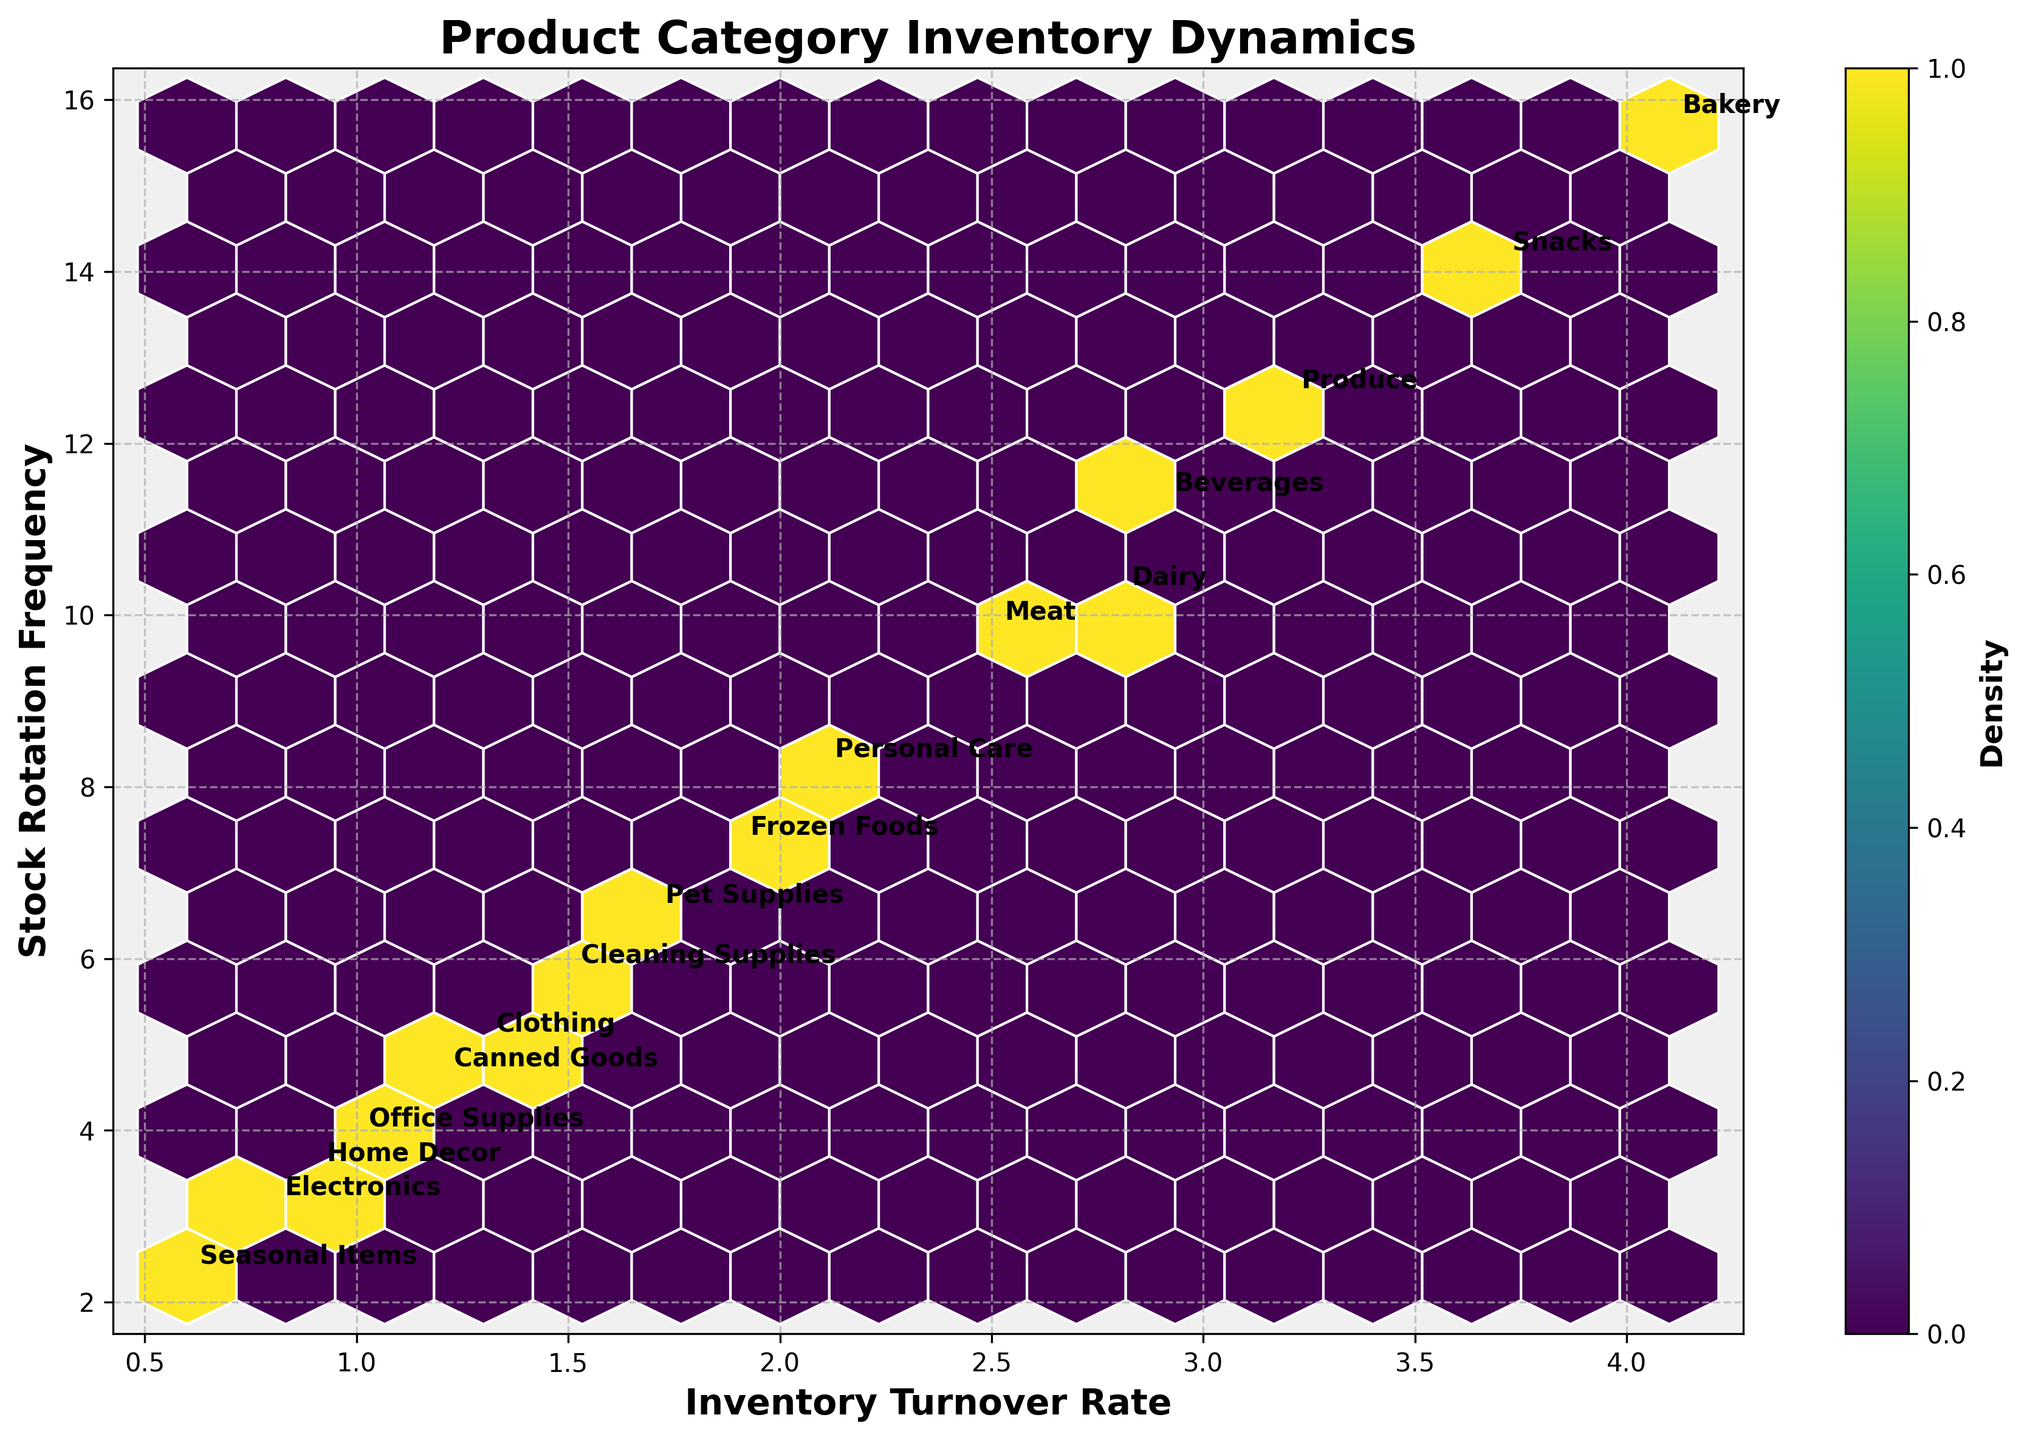What is the title of the figure? The title of the figure is usually found at the top of the plot and generally summarizes what the figure represents.
Answer: Product Category Inventory Dynamics How many different product categories are represented in the plot? Count the number of unique data labels annotated next to the data points in the plot.
Answer: 16 Which product category has the highest inventory turnover rate? Look for the data point with the highest x-value label and note the corresponding product category.
Answer: Bakery Where is the density of data points the highest, in terms of both inventory turnover rate and stock rotation frequency? The density will be highest where the color of the hexagons shows the strongest intensity (darkest color in the viridis color map). Check the intersection of higher density hexagons with the axis.
Answer: Around (3, 10-13) How do the inventory turnover rates of 'Frozen Foods' and 'Snacks' compare? Which one is higher? Locate both categories' data points and compare their x-values.
Answer: Snacks On average, do product categories with high stock rotation frequency also have high inventory turnover rates? Determine if most data points with high z-values are also associated with high y-values.
Answer: Yes Identify the product category with the lowest stock rotation frequency. What's its turnover rate? Look for the data point with the lowest z-value, then check its corresponding x-value.
Answer: Seasonal Items, Turnover Rate: 0.6 How does the density of Electronics compare to that of Dairy? Observe the density color of hexagons around the data points for Electronics and Dairy using the color bar for reference.
Answer: Electronics has lower density Which product categories have a stock rotation frequency between 10 and 15? Identify the data points that fall within the y-range of 10 to 15 and note the corresponding product labels.
Answer: Produce, Dairy, Snacks, Beverages Is there a clear correlation between inventory turnover rate and stock rotation frequency? Assess the general trend in the distribution of data points to determine if higher turnover rates correspond with higher stock rotation frequencies.
Answer: Yes 